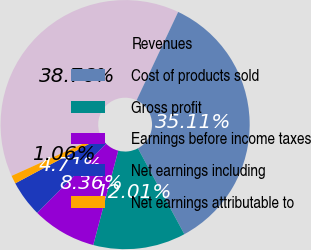Convert chart. <chart><loc_0><loc_0><loc_500><loc_500><pie_chart><fcel>Revenues<fcel>Cost of products sold<fcel>Gross profit<fcel>Earnings before income taxes<fcel>Net earnings including<fcel>Net earnings attributable to<nl><fcel>38.76%<fcel>35.11%<fcel>12.01%<fcel>8.36%<fcel>4.71%<fcel>1.06%<nl></chart> 